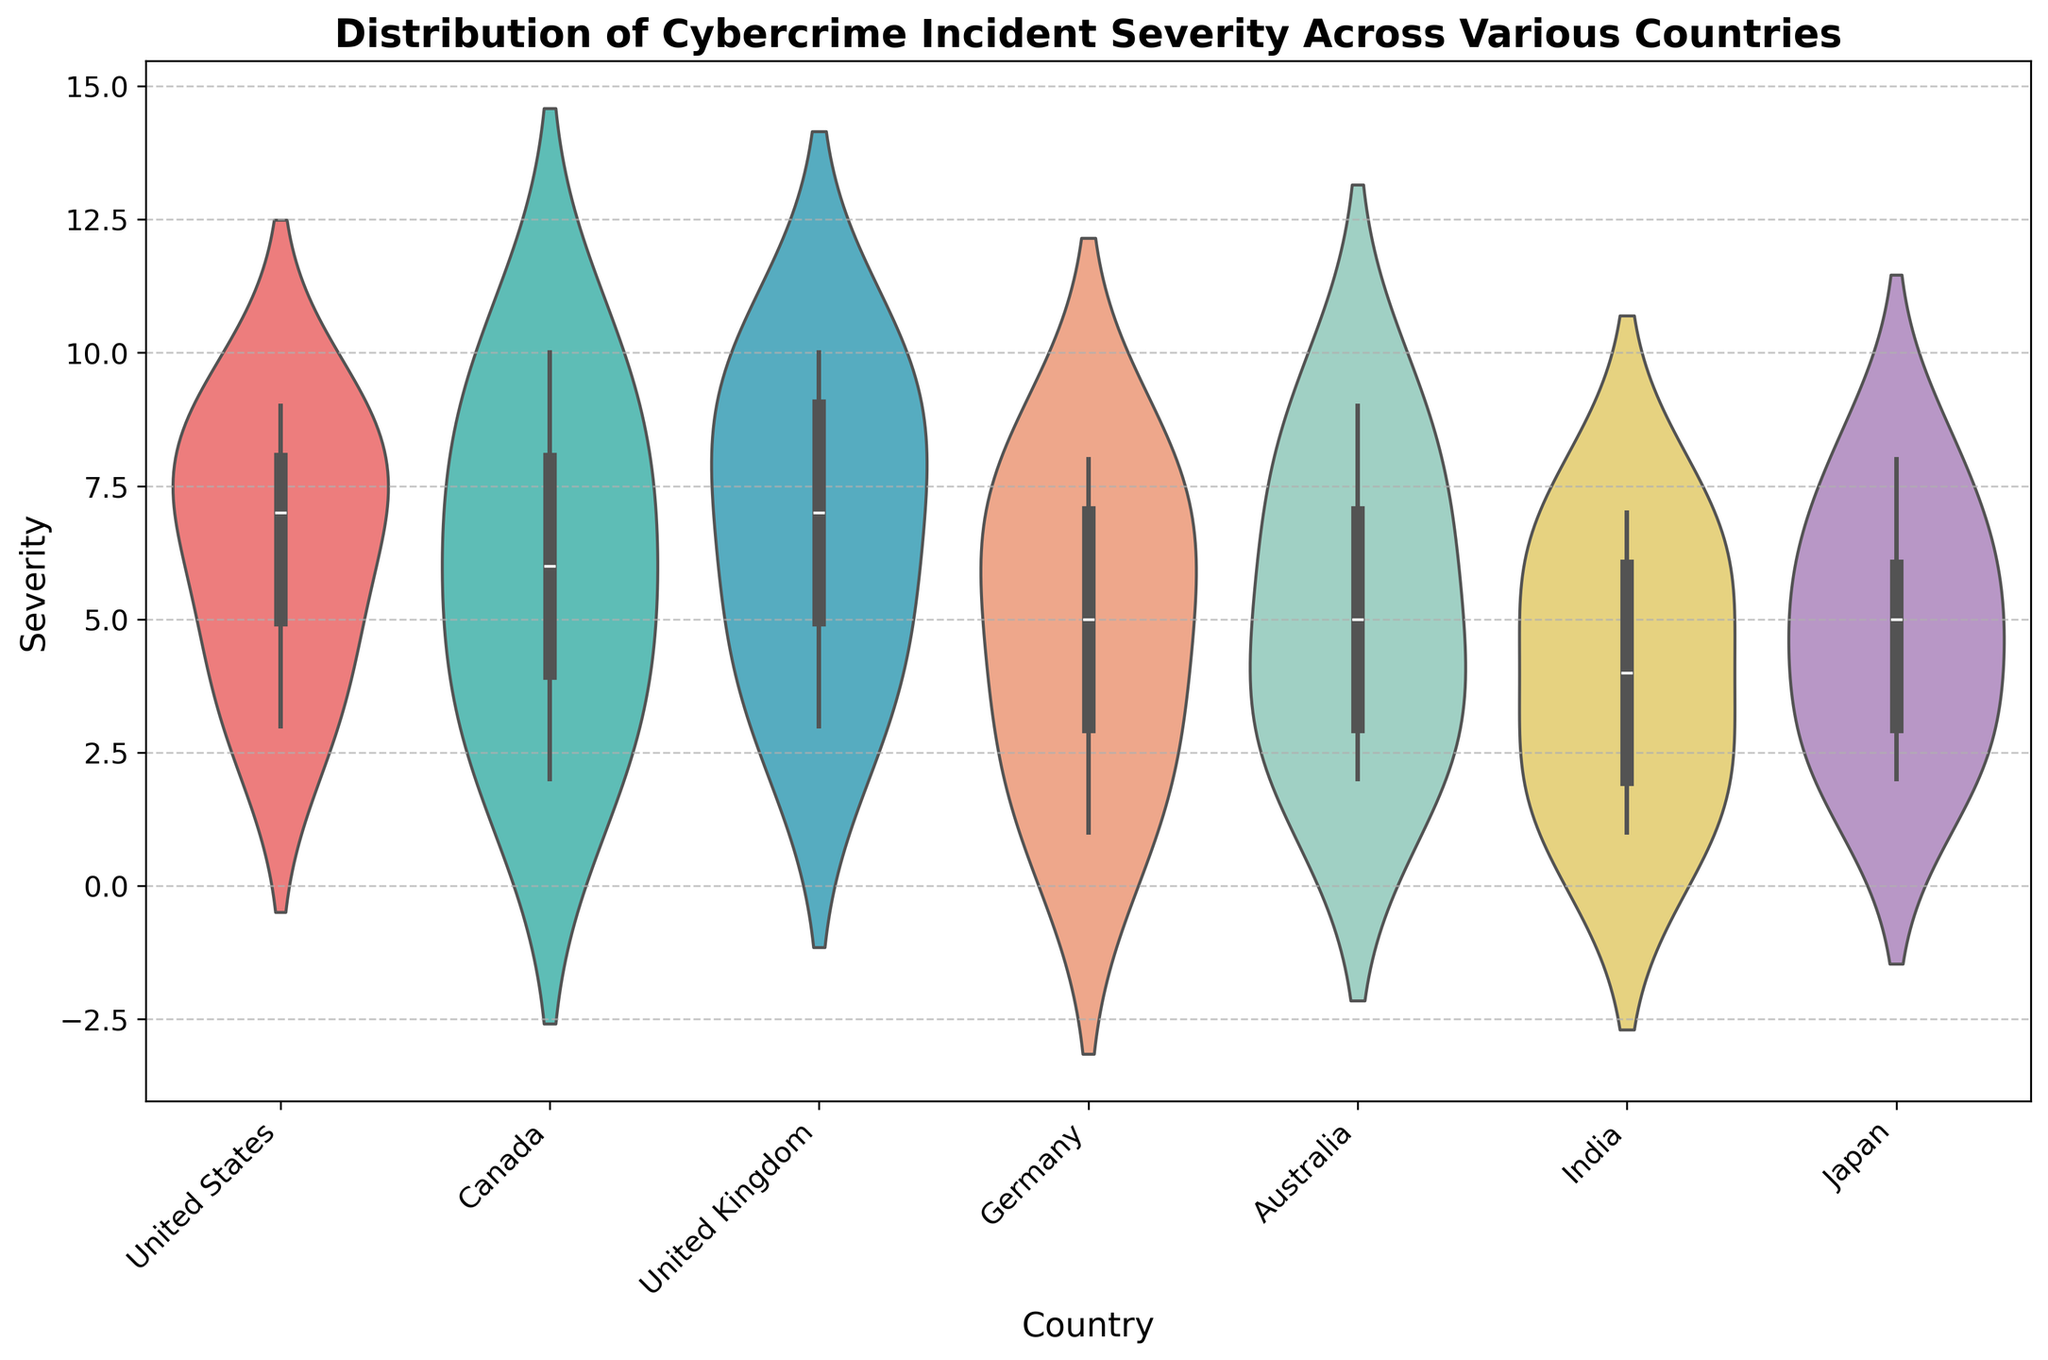What is the title of the figure? The title of the figure is written at the top and summarizes the main subject of the plot. The title helps in understanding the central theme, which in this case is 'Distribution of Cybercrime Incident Severity Across Various Countries'.
Answer: Distribution of Cybercrime Incident Severity Across Various Countries Which country has the highest maximum severity score? In a violin plot, the maximum severity score for each country can be observed at the topmost point within each violin. By comparing the top points, we see that Canada and the United Kingdom have the highest maximum scores.
Answer: Canada and United Kingdom What is the range of severity scores for Germany? The range of severity scores for a country in a violin plot can be determined by identifying the lowest and highest points of the distribution. For Germany, the lowest point is 1 and the highest is 8.
Answer: 1 to 8 How many countries have a minimum severity score of 2? To determine this, we look at the bottom of each violin. The countries with a minimum score of 2 are Australia, Canada, India, and Japan.
Answer: 4 Which country shows the most symmetric distribution of severity scores? Symmetry in a violin plot can be determined by observing whether the shape is evenly distributed on both sides of the center line. Japan's distribution appears almost symmetrical.
Answer: Japan Which country has the widest distribution of severity scores? The widest distribution can be identified by the range of values the violin covers vertically. Canada’s distribution ranges from 2 to 10, indicating it has the widest distribution of severity scores.
Answer: Canada What is the median severity score for the United States? The median is represented by the thicker line in the middle of the box within the violin. For the United States, this line is around the 7 mark.
Answer: 7 Comparing the United Kingdom and Australia, which country appears to have a larger spread in severity scores? A larger spread is indicated by a longer vertical range. By comparing the violins, the United Kingdom has a larger spread from 3 to 10, while Australia's range is from 2 to 9.
Answer: United Kingdom What is the approximate interquartile range (IQR) of severity scores for India? The IQR is the range between the first and third quartiles, shown within the central box of the violin. For India, this seems to range from 2 to 7.
Answer: 5 Does any country have a bimodal distribution of severity scores? A bimodal distribution would show two distinct peaks within the violin plot. None of the countries exhibit a clear bimodal distribution in this figure.
Answer: No 